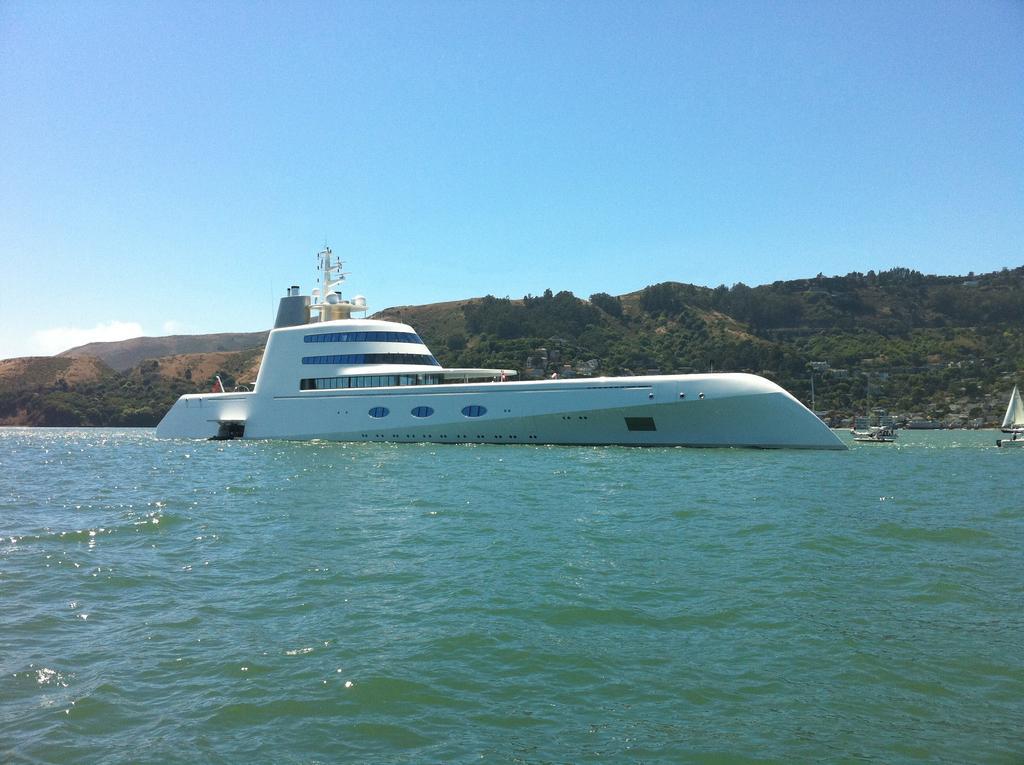In one or two sentences, can you explain what this image depicts? In this image, we can see a ship floating on the water. There is hill in the middle of the image. There is a sky at the top of the image. 